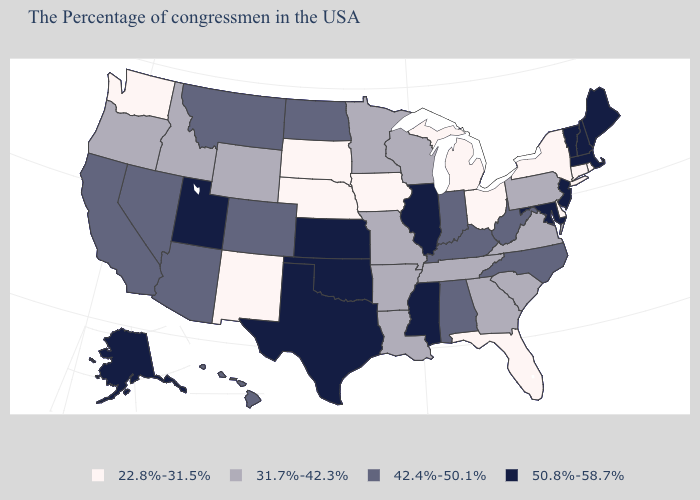Which states have the highest value in the USA?
Concise answer only. Maine, Massachusetts, New Hampshire, Vermont, New Jersey, Maryland, Illinois, Mississippi, Kansas, Oklahoma, Texas, Utah, Alaska. Which states have the lowest value in the USA?
Answer briefly. Rhode Island, Connecticut, New York, Delaware, Ohio, Florida, Michigan, Iowa, Nebraska, South Dakota, New Mexico, Washington. What is the highest value in the USA?
Be succinct. 50.8%-58.7%. What is the highest value in the USA?
Be succinct. 50.8%-58.7%. What is the value of Illinois?
Short answer required. 50.8%-58.7%. What is the value of Delaware?
Give a very brief answer. 22.8%-31.5%. Does Missouri have the lowest value in the MidWest?
Quick response, please. No. Does Mississippi have a higher value than Kansas?
Write a very short answer. No. Does Virginia have the lowest value in the USA?
Answer briefly. No. Does New Jersey have the lowest value in the USA?
Quick response, please. No. Name the states that have a value in the range 31.7%-42.3%?
Answer briefly. Pennsylvania, Virginia, South Carolina, Georgia, Tennessee, Wisconsin, Louisiana, Missouri, Arkansas, Minnesota, Wyoming, Idaho, Oregon. Among the states that border Arkansas , which have the highest value?
Give a very brief answer. Mississippi, Oklahoma, Texas. What is the highest value in the USA?
Be succinct. 50.8%-58.7%. Does Mississippi have a lower value than Wyoming?
Concise answer only. No. Name the states that have a value in the range 22.8%-31.5%?
Concise answer only. Rhode Island, Connecticut, New York, Delaware, Ohio, Florida, Michigan, Iowa, Nebraska, South Dakota, New Mexico, Washington. 